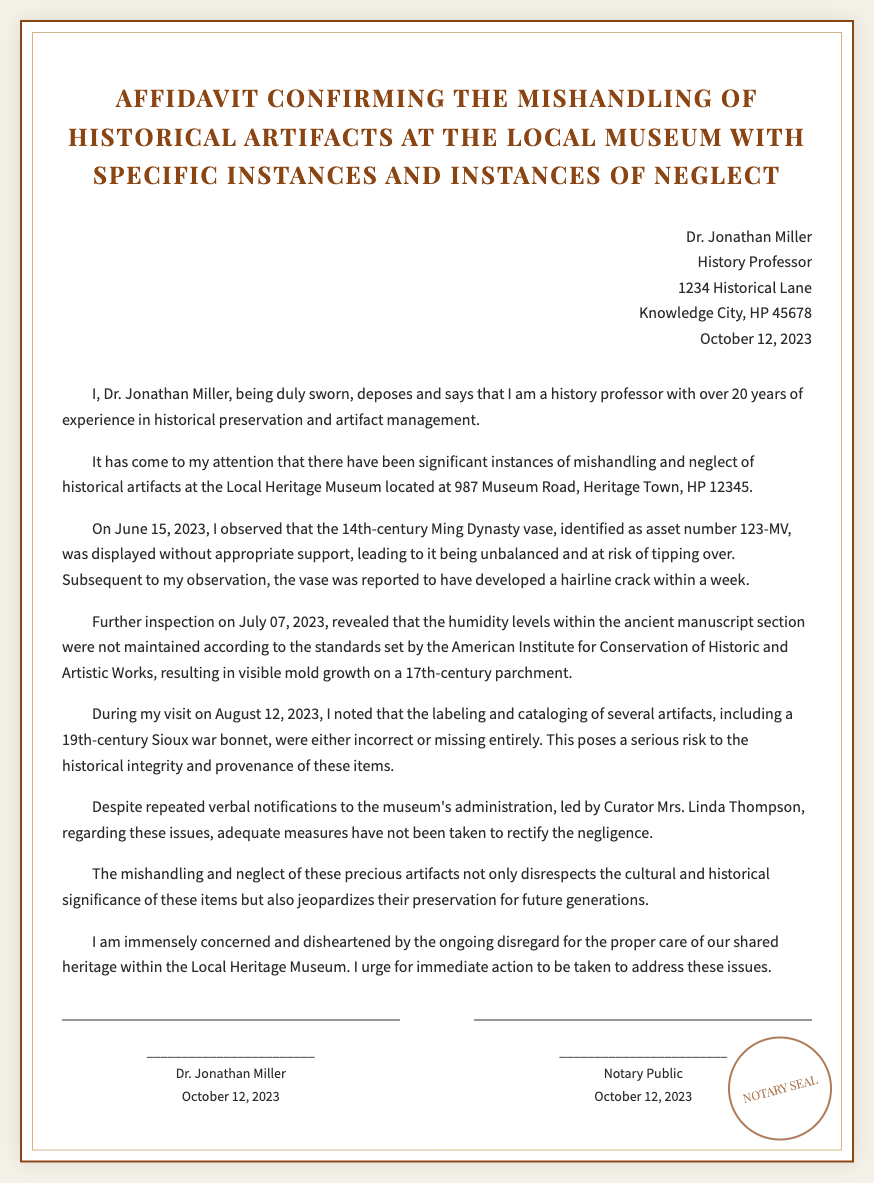What is the name of the affiant? The name of the affiant is mentioned in the document as Dr. Jonathan Miller.
Answer: Dr. Jonathan Miller What date was the affidavit signed? The document includes a date when the affidavit was signed, which is October 12, 2023.
Answer: October 12, 2023 What is the asset number of the 14th-century Ming Dynasty vase? The document specifies the asset number of the vase, which is 123-MV.
Answer: 123-MV What issue was reported about the 17th-century parchment? The document states that the 17th-century parchment developed visible mold growth due to improper humidity levels.
Answer: Mold growth Who is the curator mentioned in the affidavit? The affidavit identifies the curator responsible as Mrs. Linda Thompson.
Answer: Mrs. Linda Thompson On what date was the 14th-century vase observed? The date when the vase was observed as mishandled is June 15, 2023.
Answer: June 15, 2023 What type of item was the 19th-century Sioux artifact? The document describes the item as a war bonnet.
Answer: War bonnet What is Dr. Miller's profession? The document indicates that Dr. Miller holds the position of a history professor.
Answer: History professor What is expressed concern over in the affidavit? The affidavit expresses concern over the ongoing disregard for proper care of historical artifacts.
Answer: Disregard for artifacts 